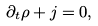<formula> <loc_0><loc_0><loc_500><loc_500>\partial _ { t } \rho + j = 0 ,</formula> 